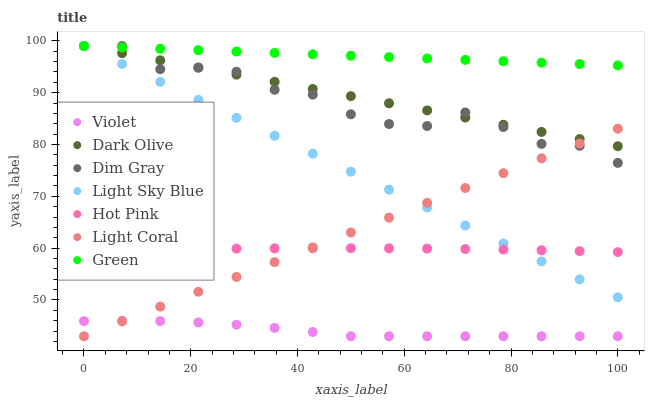Does Violet have the minimum area under the curve?
Answer yes or no. Yes. Does Green have the maximum area under the curve?
Answer yes or no. Yes. Does Dark Olive have the minimum area under the curve?
Answer yes or no. No. Does Dark Olive have the maximum area under the curve?
Answer yes or no. No. Is Green the smoothest?
Answer yes or no. Yes. Is Dim Gray the roughest?
Answer yes or no. Yes. Is Dark Olive the smoothest?
Answer yes or no. No. Is Dark Olive the roughest?
Answer yes or no. No. Does Light Coral have the lowest value?
Answer yes or no. Yes. Does Dark Olive have the lowest value?
Answer yes or no. No. Does Green have the highest value?
Answer yes or no. Yes. Does Light Coral have the highest value?
Answer yes or no. No. Is Violet less than Dim Gray?
Answer yes or no. Yes. Is Light Sky Blue greater than Violet?
Answer yes or no. Yes. Does Dark Olive intersect Light Sky Blue?
Answer yes or no. Yes. Is Dark Olive less than Light Sky Blue?
Answer yes or no. No. Is Dark Olive greater than Light Sky Blue?
Answer yes or no. No. Does Violet intersect Dim Gray?
Answer yes or no. No. 